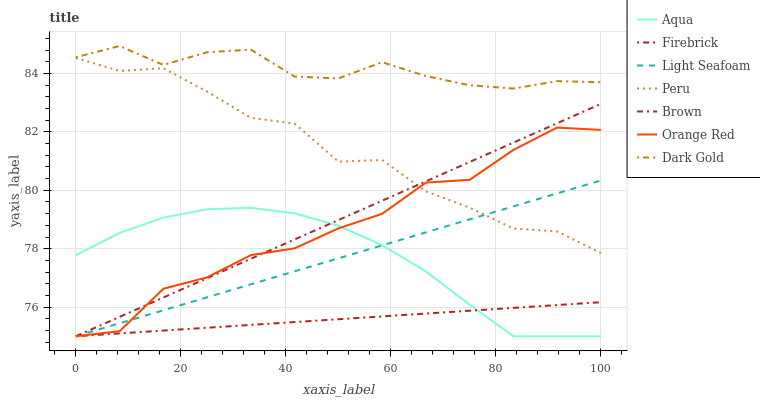Does Firebrick have the minimum area under the curve?
Answer yes or no. Yes. Does Dark Gold have the maximum area under the curve?
Answer yes or no. Yes. Does Dark Gold have the minimum area under the curve?
Answer yes or no. No. Does Firebrick have the maximum area under the curve?
Answer yes or no. No. Is Brown the smoothest?
Answer yes or no. Yes. Is Peru the roughest?
Answer yes or no. Yes. Is Dark Gold the smoothest?
Answer yes or no. No. Is Dark Gold the roughest?
Answer yes or no. No. Does Dark Gold have the lowest value?
Answer yes or no. No. Does Firebrick have the highest value?
Answer yes or no. No. Is Firebrick less than Peru?
Answer yes or no. Yes. Is Dark Gold greater than Firebrick?
Answer yes or no. Yes. Does Firebrick intersect Peru?
Answer yes or no. No. 